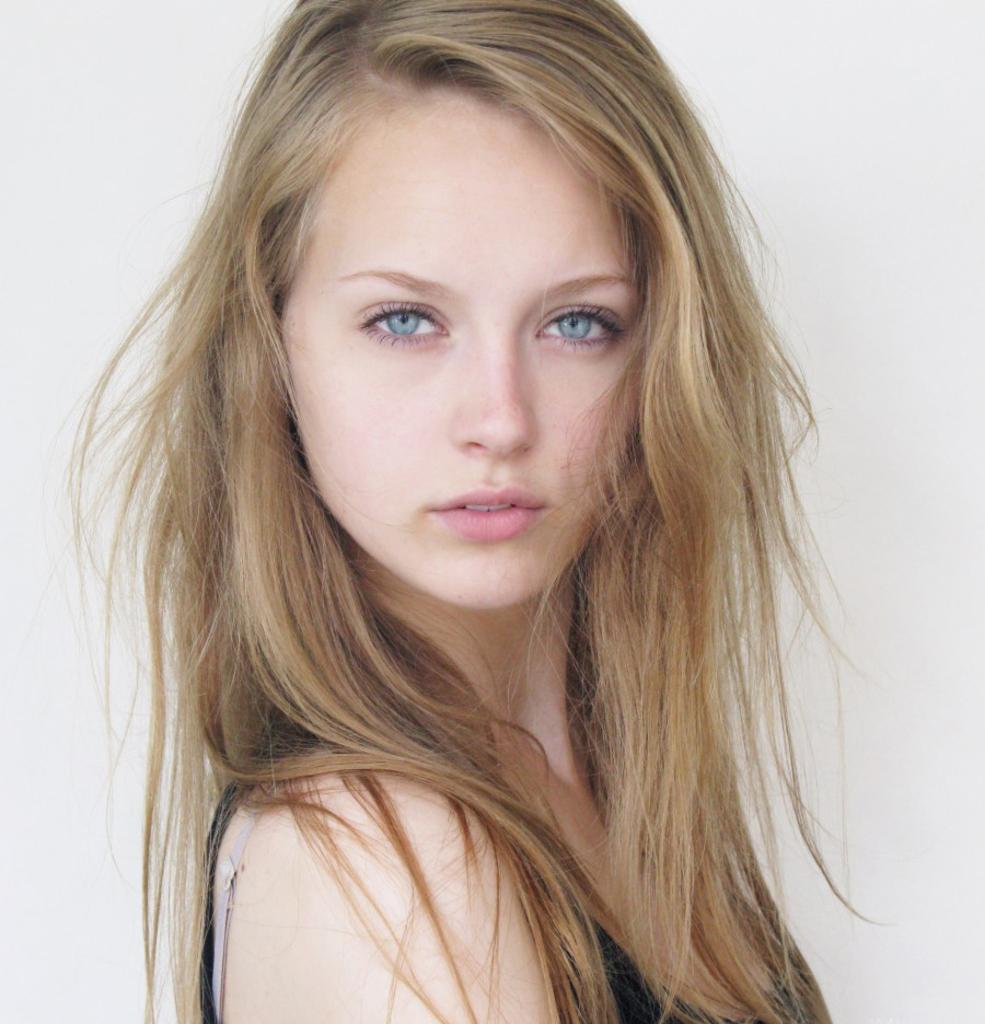Who is the main subject in the image? There is a lady in the center of the image. What is the lady wearing? The lady is wearing a black dress. What can be seen in the background of the image? There is a wall in the background of the image. How many dimes are on the lady's head in the image? There are no dimes present on the lady's head in the image. What type of thing is the lady holding in the image? The image does not show the lady holding any specific thing. 